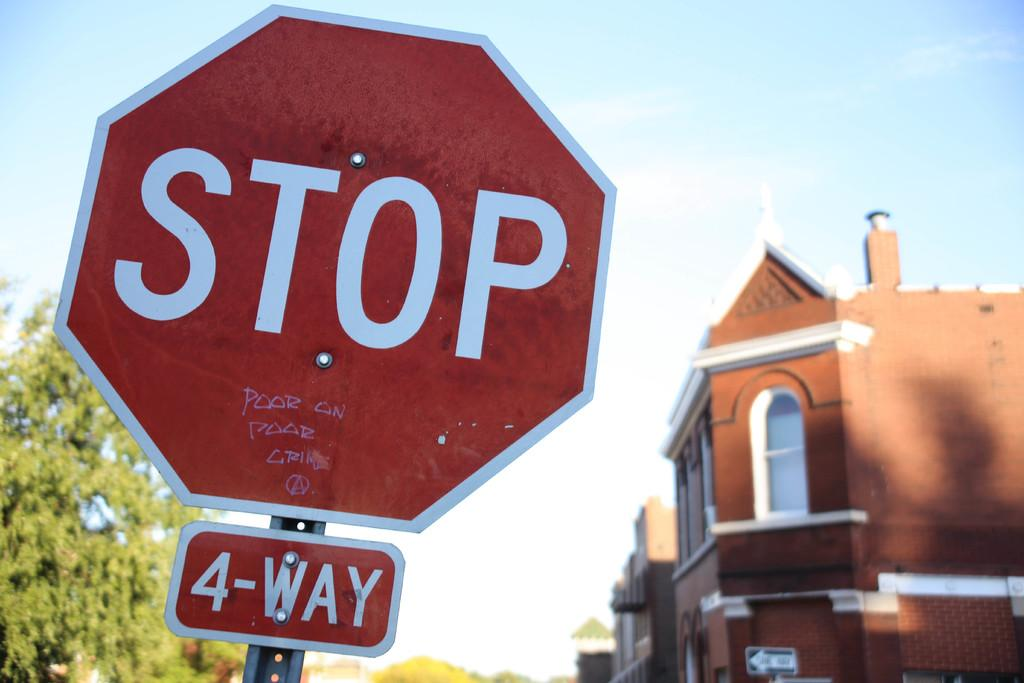<image>
Describe the image concisely. A red and white stop sign with a four way smaller sign on the underside of it. 